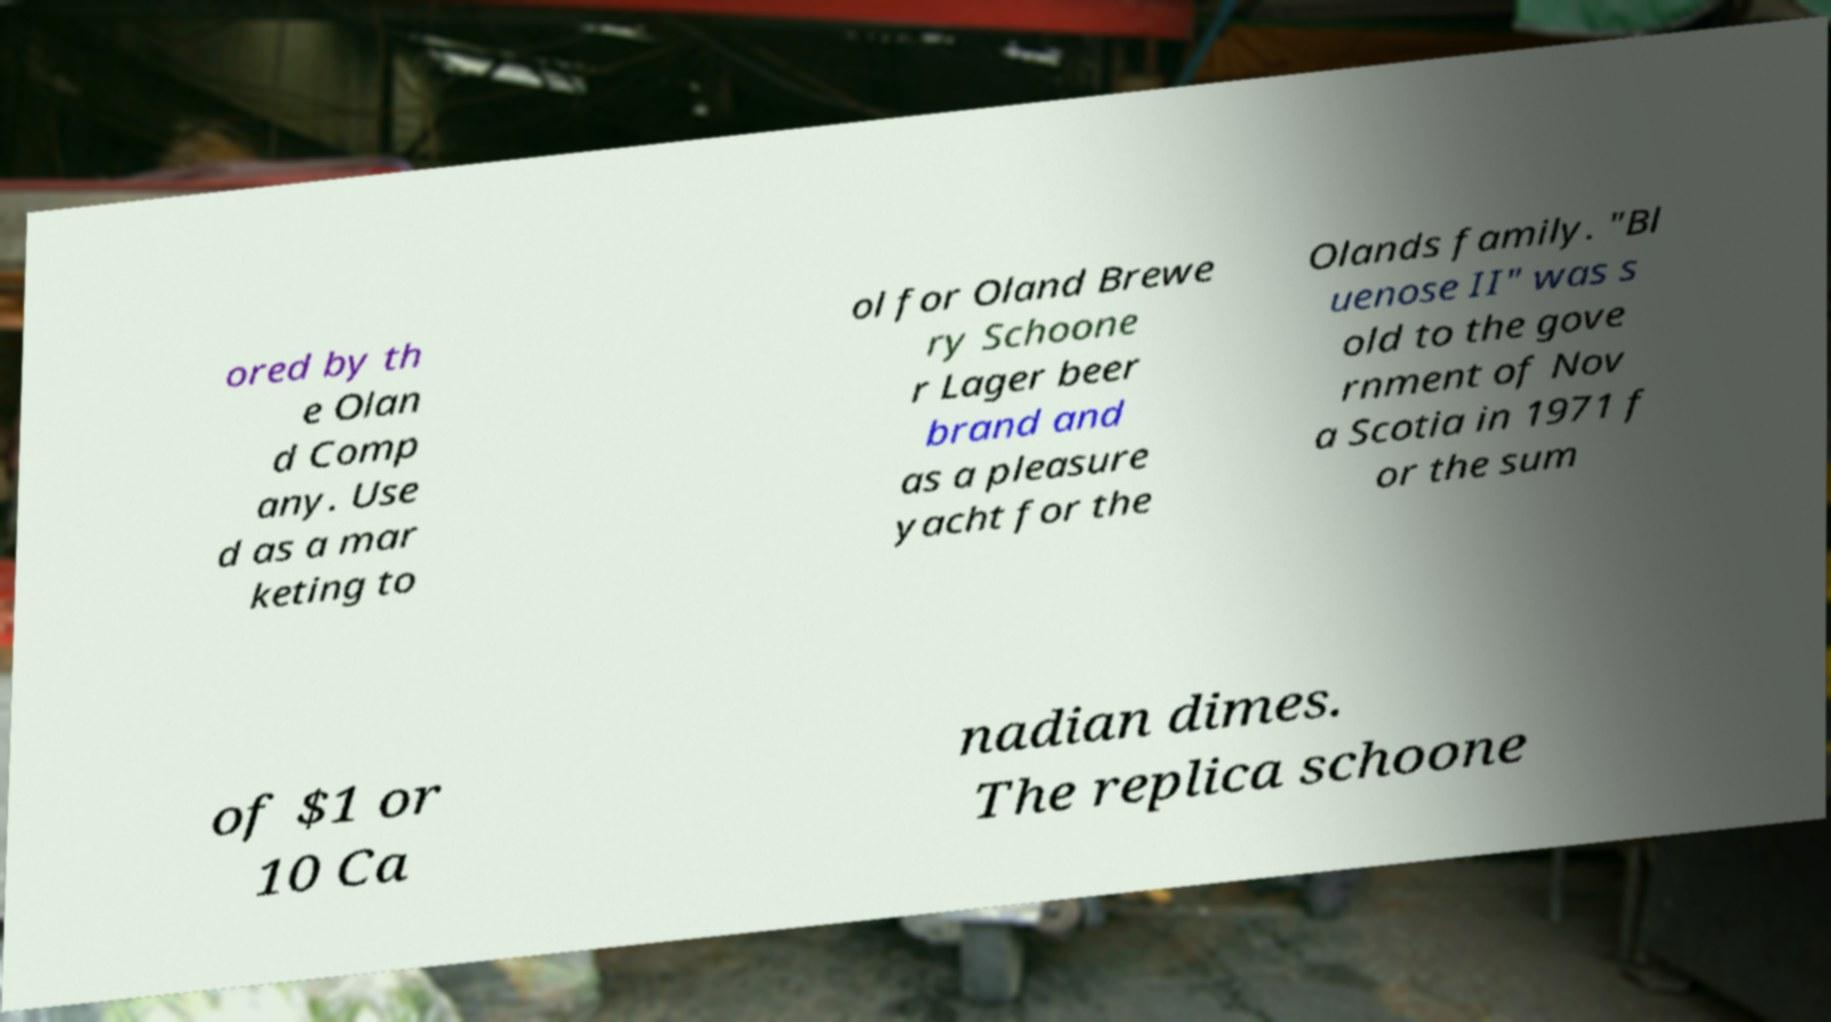There's text embedded in this image that I need extracted. Can you transcribe it verbatim? ored by th e Olan d Comp any. Use d as a mar keting to ol for Oland Brewe ry Schoone r Lager beer brand and as a pleasure yacht for the Olands family. "Bl uenose II" was s old to the gove rnment of Nov a Scotia in 1971 f or the sum of $1 or 10 Ca nadian dimes. The replica schoone 